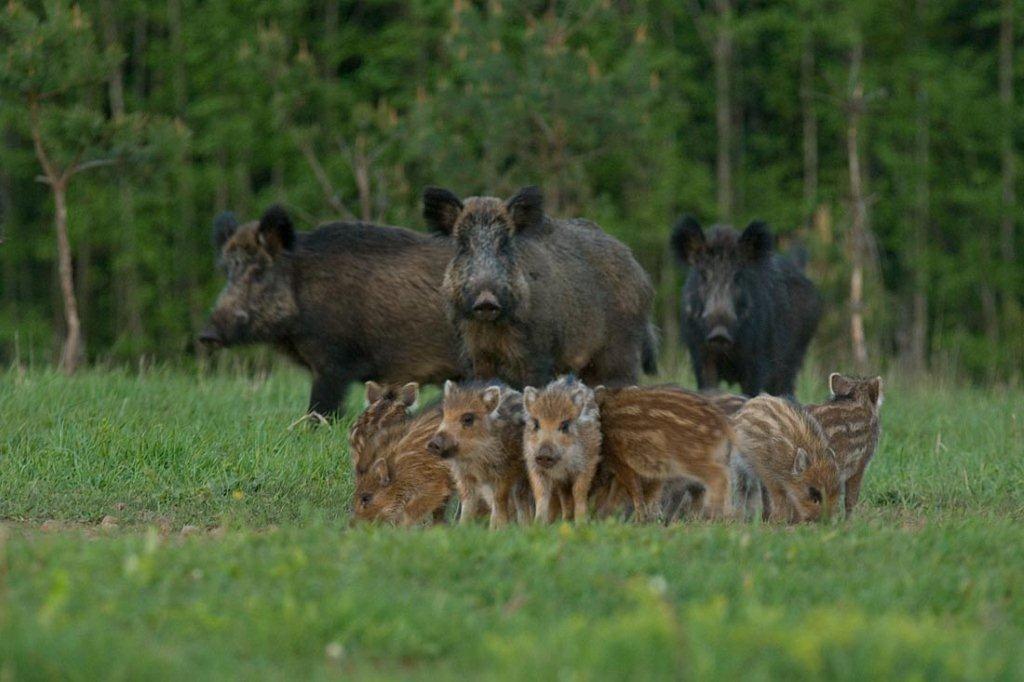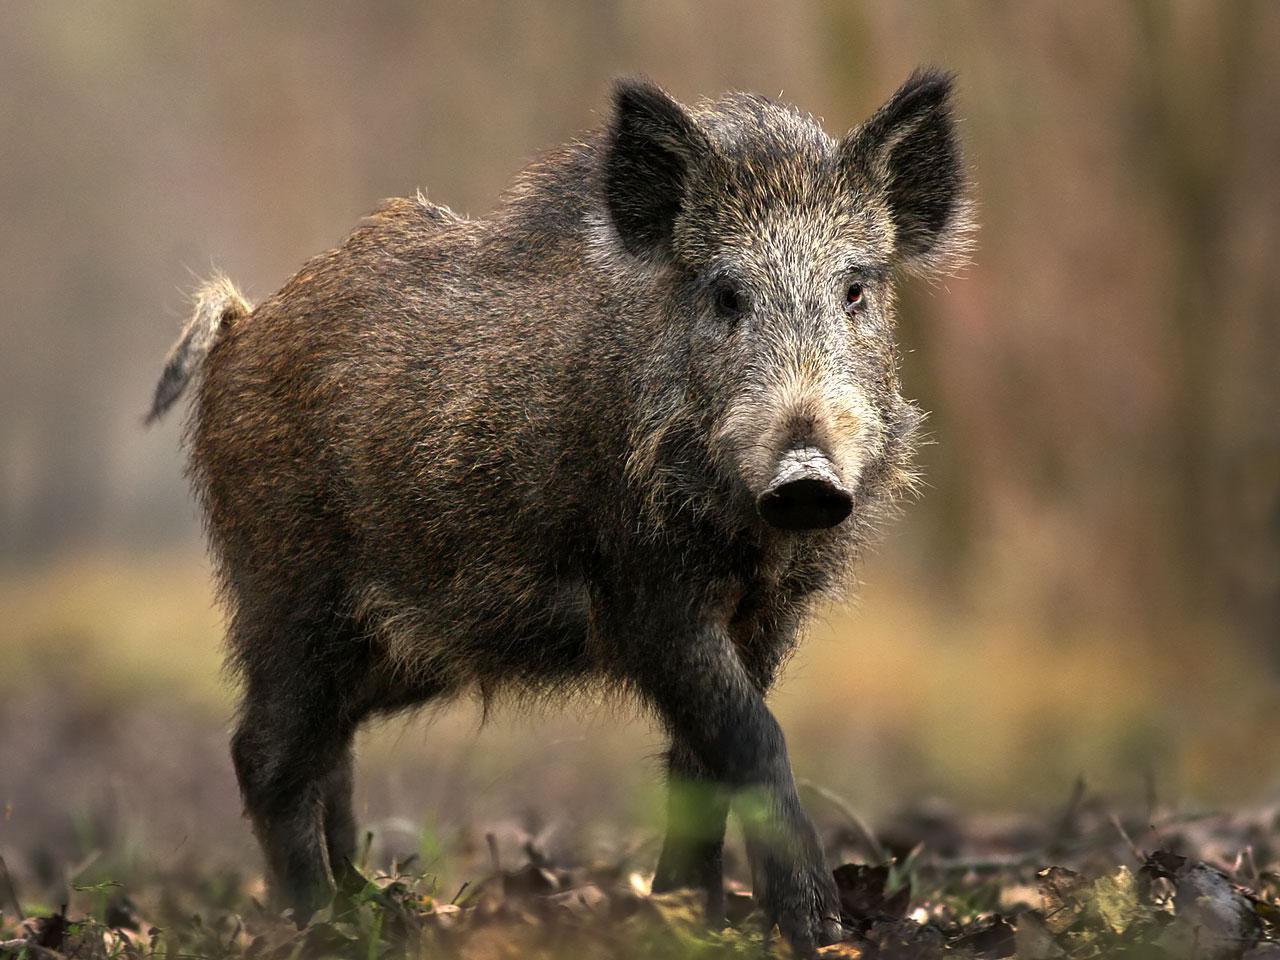The first image is the image on the left, the second image is the image on the right. Examine the images to the left and right. Is the description "Three adult wild pigs stand in green grass with at least one baby pig whose hair has distinctive stripes." accurate? Answer yes or no. Yes. The first image is the image on the left, the second image is the image on the right. Evaluate the accuracy of this statement regarding the images: "The right image contains exactly one boar.". Is it true? Answer yes or no. Yes. 